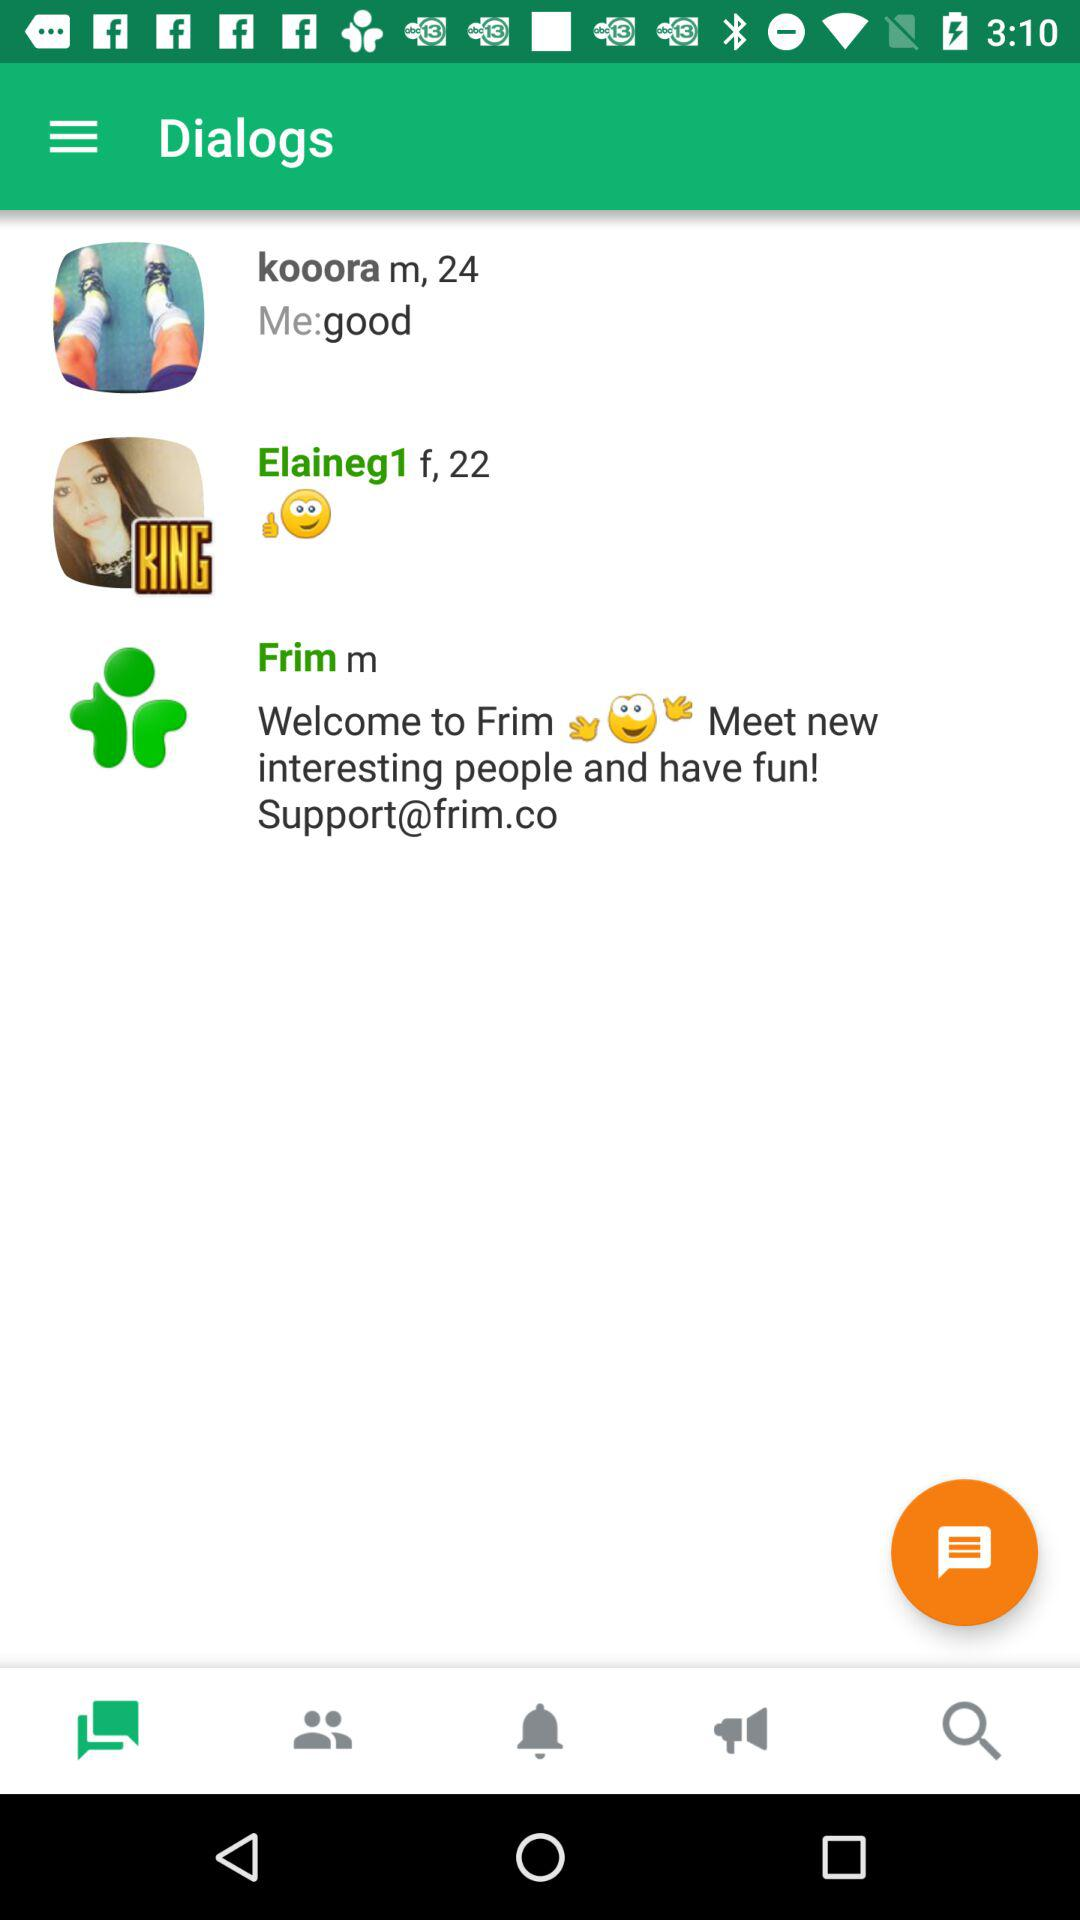How many notifications are there in the menu bar?
When the provided information is insufficient, respond with <no answer>. <no answer> 